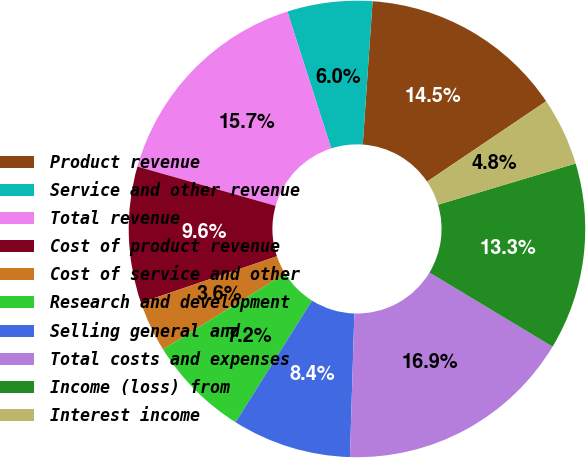Convert chart to OTSL. <chart><loc_0><loc_0><loc_500><loc_500><pie_chart><fcel>Product revenue<fcel>Service and other revenue<fcel>Total revenue<fcel>Cost of product revenue<fcel>Cost of service and other<fcel>Research and development<fcel>Selling general and<fcel>Total costs and expenses<fcel>Income (loss) from<fcel>Interest income<nl><fcel>14.46%<fcel>6.02%<fcel>15.66%<fcel>9.64%<fcel>3.61%<fcel>7.23%<fcel>8.43%<fcel>16.87%<fcel>13.25%<fcel>4.82%<nl></chart> 